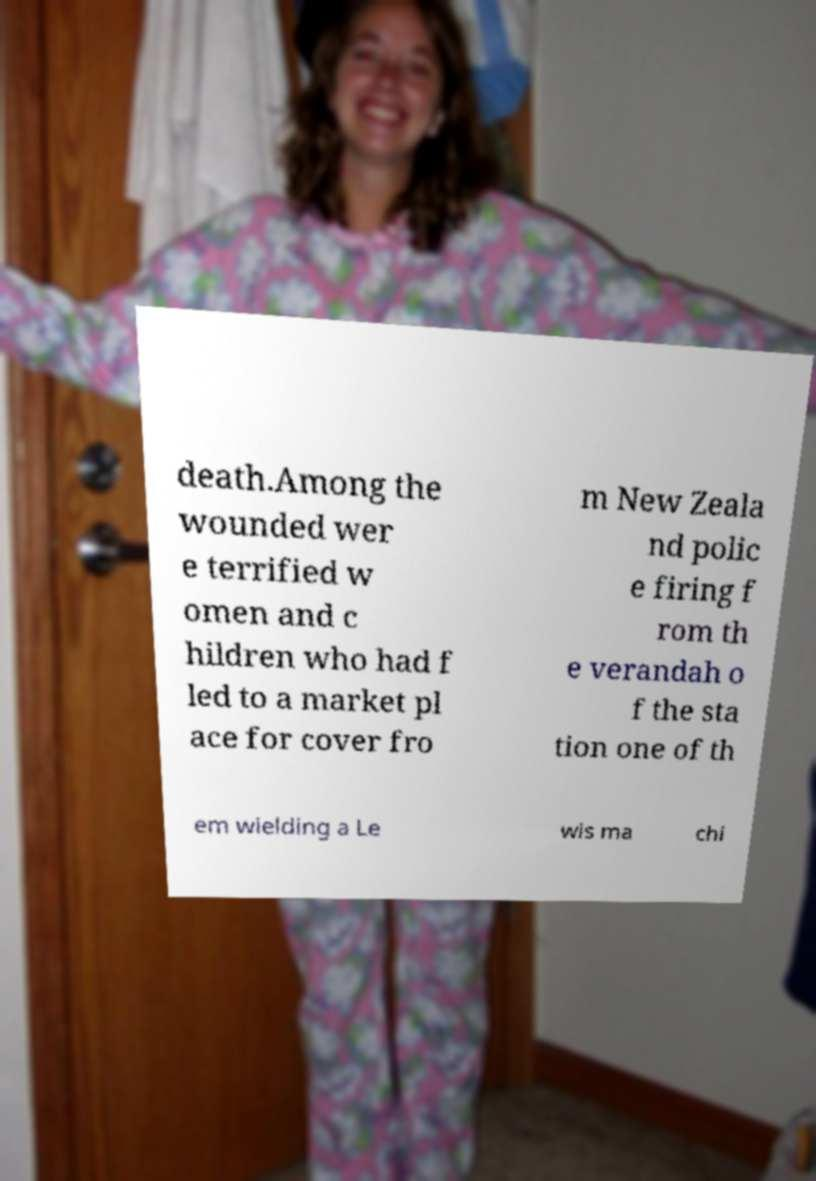Can you read and provide the text displayed in the image?This photo seems to have some interesting text. Can you extract and type it out for me? death.Among the wounded wer e terrified w omen and c hildren who had f led to a market pl ace for cover fro m New Zeala nd polic e firing f rom th e verandah o f the sta tion one of th em wielding a Le wis ma chi 